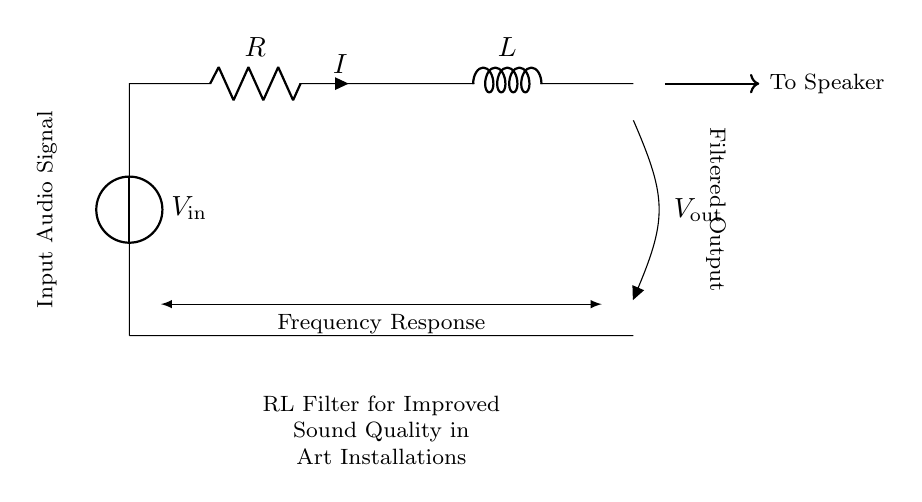What components are included in this circuit? The circuit contains a voltage source, a resistor, and an inductor, which are indicated by their respective symbols.
Answer: Voltage source, resistor, inductor What does the output voltage represent? The output voltage is the voltage across the inductor, which is filtered from the incoming audio signal.
Answer: Filtered output What is the current direction in this circuit? The current is indicated by the arrow labeled "I," showing the flow from the voltage source, through the resistor and inductor, to the output.
Answer: From voltage source to output How does an RL filter improve sound quality? An RL filter attenuates high-frequency noise while allowing lower frequencies to pass, enhancing the overall audio clarity and quality.
Answer: By attenuating high frequencies What is the primary function of the resistor in this circuit? The resistor serves to limit the current flowing through the circuit and works with the inductor to establish the filter's characteristics.
Answer: Limit current What happens to the frequency response as resistance increases? Increasing resistance typically shifts the cut-off frequency of the filter, changing how it responds to different audio signals, thus altering the sound quality.
Answer: Shifts cut-off frequency What type of filter is represented by this RL arrangement? This circuit represents a low-pass filter, which allows signals with a frequency lower than a certain cutoff frequency to pass through while attenuating higher frequencies.
Answer: Low-pass filter 